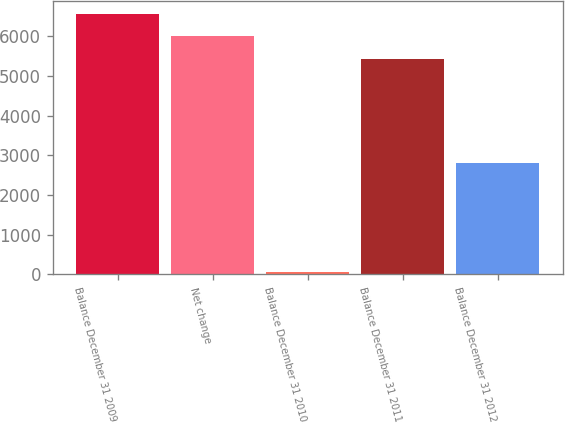<chart> <loc_0><loc_0><loc_500><loc_500><bar_chart><fcel>Balance December 31 2009<fcel>Net change<fcel>Balance December 31 2010<fcel>Balance December 31 2011<fcel>Balance December 31 2012<nl><fcel>6547.6<fcel>5992.3<fcel>66<fcel>5437<fcel>2797<nl></chart> 